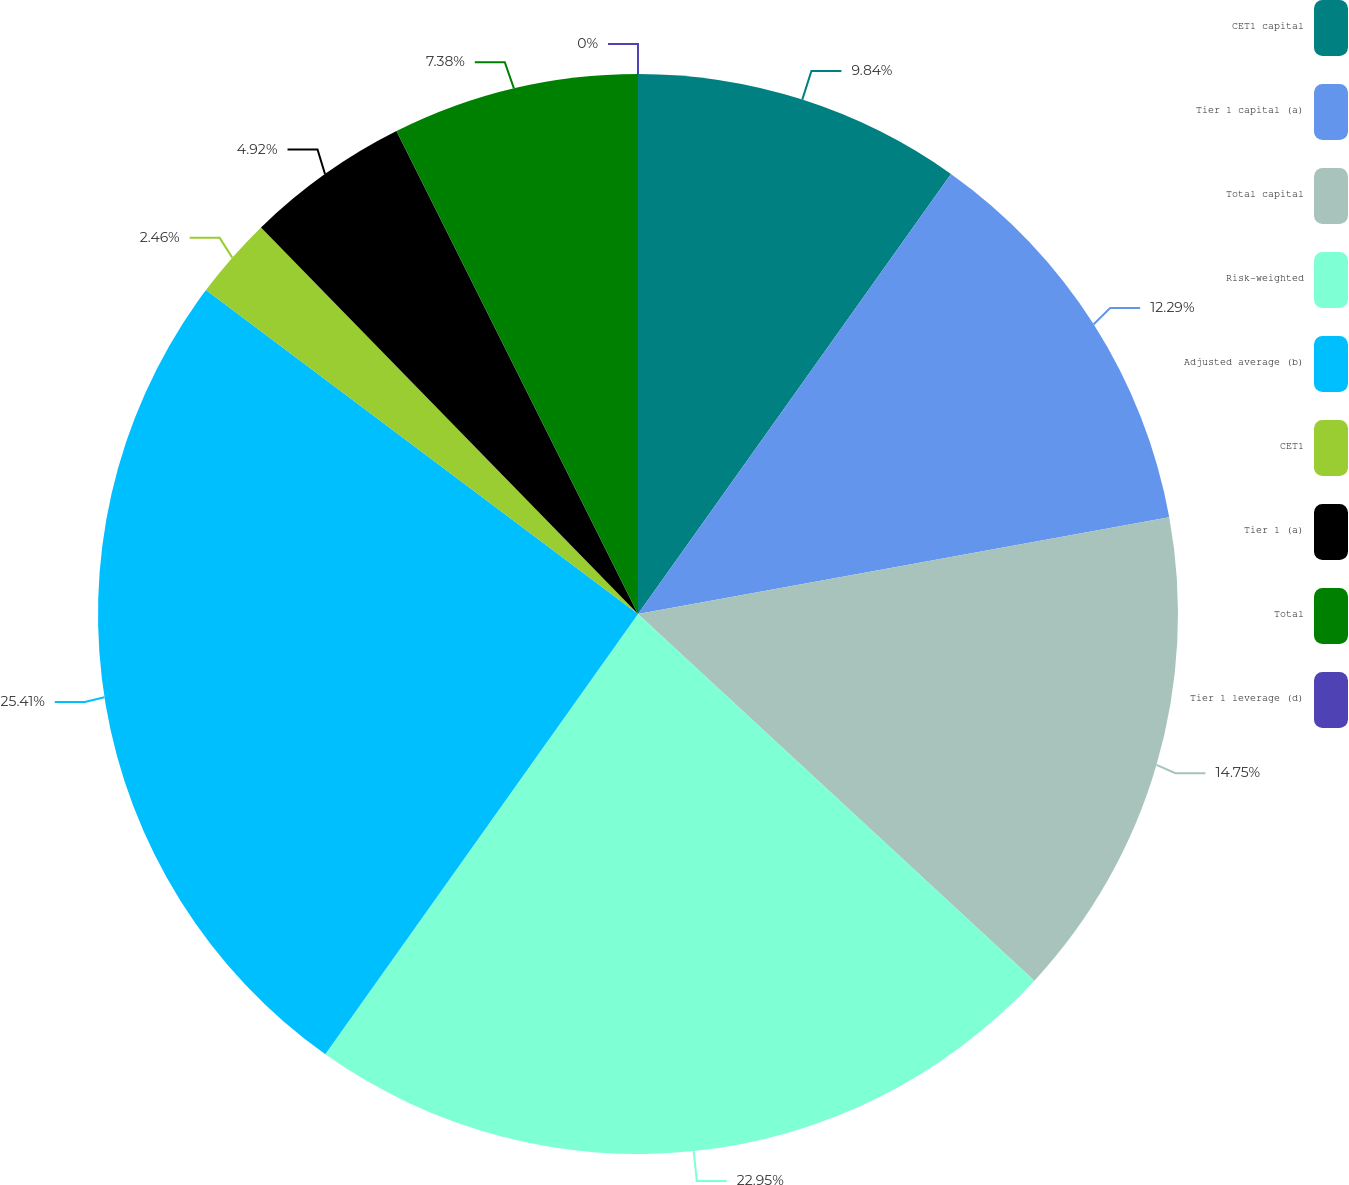Convert chart. <chart><loc_0><loc_0><loc_500><loc_500><pie_chart><fcel>CET1 capital<fcel>Tier 1 capital (a)<fcel>Total capital<fcel>Risk-weighted<fcel>Adjusted average (b)<fcel>CET1<fcel>Tier 1 (a)<fcel>Total<fcel>Tier 1 leverage (d)<nl><fcel>9.84%<fcel>12.29%<fcel>14.75%<fcel>22.95%<fcel>25.41%<fcel>2.46%<fcel>4.92%<fcel>7.38%<fcel>0.0%<nl></chart> 